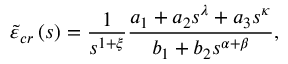Convert formula to latex. <formula><loc_0><loc_0><loc_500><loc_500>\tilde { \varepsilon } _ { c r } \left ( s \right ) = \frac { 1 } { s ^ { 1 + \xi } } \frac { a _ { 1 } + a _ { 2 } s ^ { \lambda } + a _ { 3 } s ^ { \kappa } } { b _ { 1 } + b _ { 2 } s ^ { \alpha + \beta } } ,</formula> 